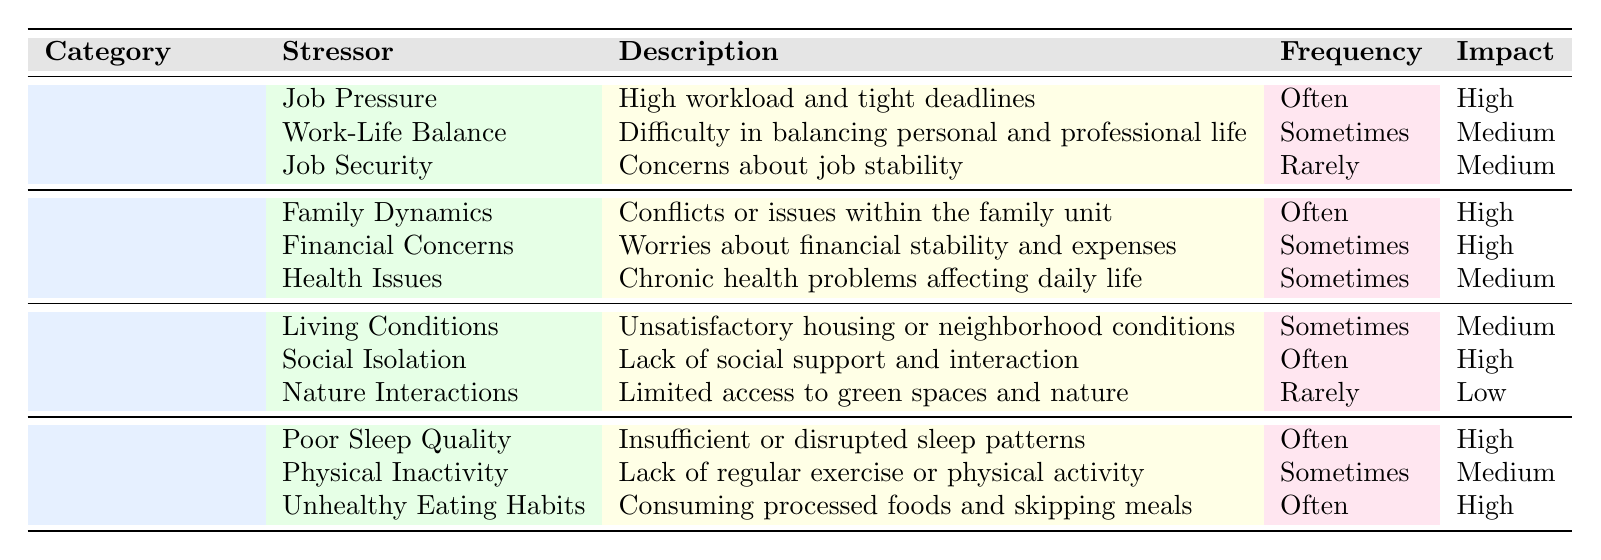What's the most frequently reported work-related stressor? Reviewing the table, "Job Pressure" is listed under "Work-Related Stressors" and is noted as occurring "Often," which is the highest frequency reported.
Answer: Job Pressure How often do clients report issues with family dynamics? The table states that "Family Dynamics" is categorized under "Personal Life Stressors" and is listed as occurring "Often."
Answer: Often Is there a stressor related to living conditions that has a high impact? Looking through the "Environmental Stressors" section, "Living Conditions" has a medium impact level, and even though the frequency is "Sometimes," there are no high impact stressors in this category.
Answer: No What is the impact level of "Financial Concerns"? Referring to the table, "Financial Concerns" is indicated to have a high impact level under the "Personal Life Stressors" category.
Answer: High Which lifestyle stressor is reported to have the highest frequency? Among the "Lifestyle Stressors," both "Poor Sleep Quality" and "Unhealthy Eating Habits" are listed as occurring "Often." Therefore, they tie for the highest frequency.
Answer: Poor Sleep Quality and Unhealthy Eating Habits Considering the impact levels, how many stressors are categorized as having a high impact? In reviewing the table, the stressors that hold a high impact level are "Job Pressure," "Family Dynamics," "Financial Concerns," "Social Isolation," "Poor Sleep Quality," and "Unhealthy Eating Habits." This yields a total of 6 stressors.
Answer: 6 Are there any environmental stressors that occur rarely? The table shows that "Nature Interactions" is categorized as an environmental stressor that occurs "Rarely."
Answer: Yes Which category has the least often reported stressors based on the table? From the table, "Environmental Stressors" has "Nature Interactions" categorized as occurring "Rarely," whereas other categories have multiples stresses occurring often or sometimes. Thus, this category has the least often reported stressors.
Answer: Environmental What is the relationship between poor sleep quality and impact level? The table indicates that "Poor Sleep Quality" is associated with a high impact level. This demonstrates a significant relationship where poor sleep quality is likely to have serious effects on overall well-being.
Answer: High Impact 